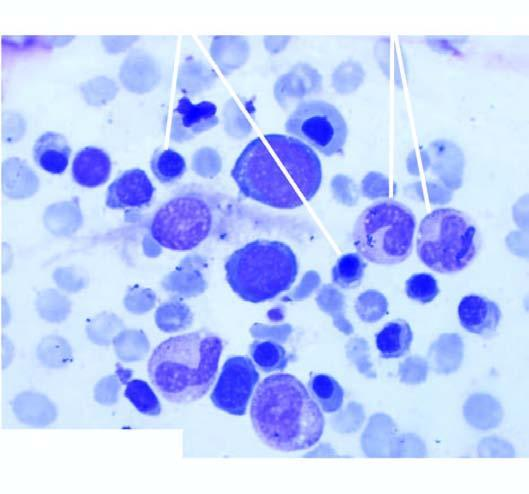does examination of bone marrow aspirate show micronormoblastic erythropoiesis?
Answer the question using a single word or phrase. Yes 